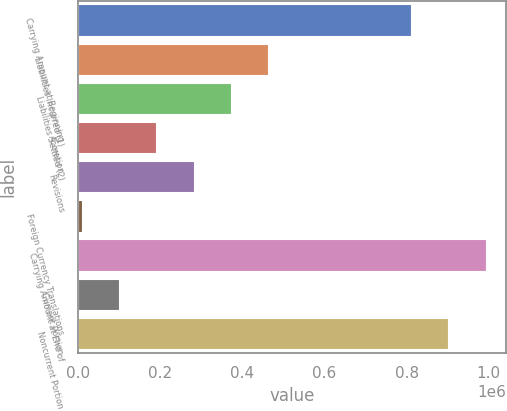<chart> <loc_0><loc_0><loc_500><loc_500><bar_chart><fcel>Carrying Amount at Beginning<fcel>Liabilities Incurred (1)<fcel>Liabilities Settled (2)<fcel>Accretion<fcel>Revisions<fcel>Foreign Currency Translations<fcel>Carrying Amount at End of<fcel>Current Portion<fcel>Noncurrent Portion<nl><fcel>811554<fcel>461756<fcel>371523<fcel>191055<fcel>281289<fcel>10587<fcel>992022<fcel>100821<fcel>901788<nl></chart> 